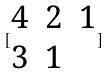<formula> <loc_0><loc_0><loc_500><loc_500>[ \begin{matrix} 4 & 2 & 1 \\ 3 & 1 \end{matrix} ]</formula> 